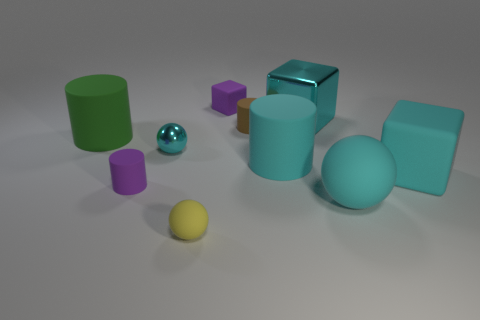What is the size of the cylinder that is the same color as the large ball?
Ensure brevity in your answer.  Large. There is a metal thing that is to the right of the tiny yellow sphere; does it have the same size as the cyan ball that is right of the big cyan shiny block?
Ensure brevity in your answer.  Yes. What size is the shiny object that is to the left of the small yellow rubber object?
Provide a succinct answer. Small. Is there a large cylinder that has the same color as the tiny metallic sphere?
Your answer should be compact. Yes. Are there any metallic objects behind the big rubber cylinder on the left side of the yellow rubber sphere?
Your response must be concise. Yes. There is a purple cylinder; does it have the same size as the yellow thing in front of the small cyan object?
Give a very brief answer. Yes. There is a small purple rubber thing that is right of the tiny matte cylinder to the left of the small rubber block; are there any cyan rubber objects behind it?
Ensure brevity in your answer.  No. There is a block that is in front of the big green thing; what material is it?
Your response must be concise. Rubber. Does the purple cube have the same size as the cyan matte ball?
Offer a very short reply. No. What color is the ball that is on the left side of the large cyan ball and in front of the purple cylinder?
Provide a succinct answer. Yellow. 